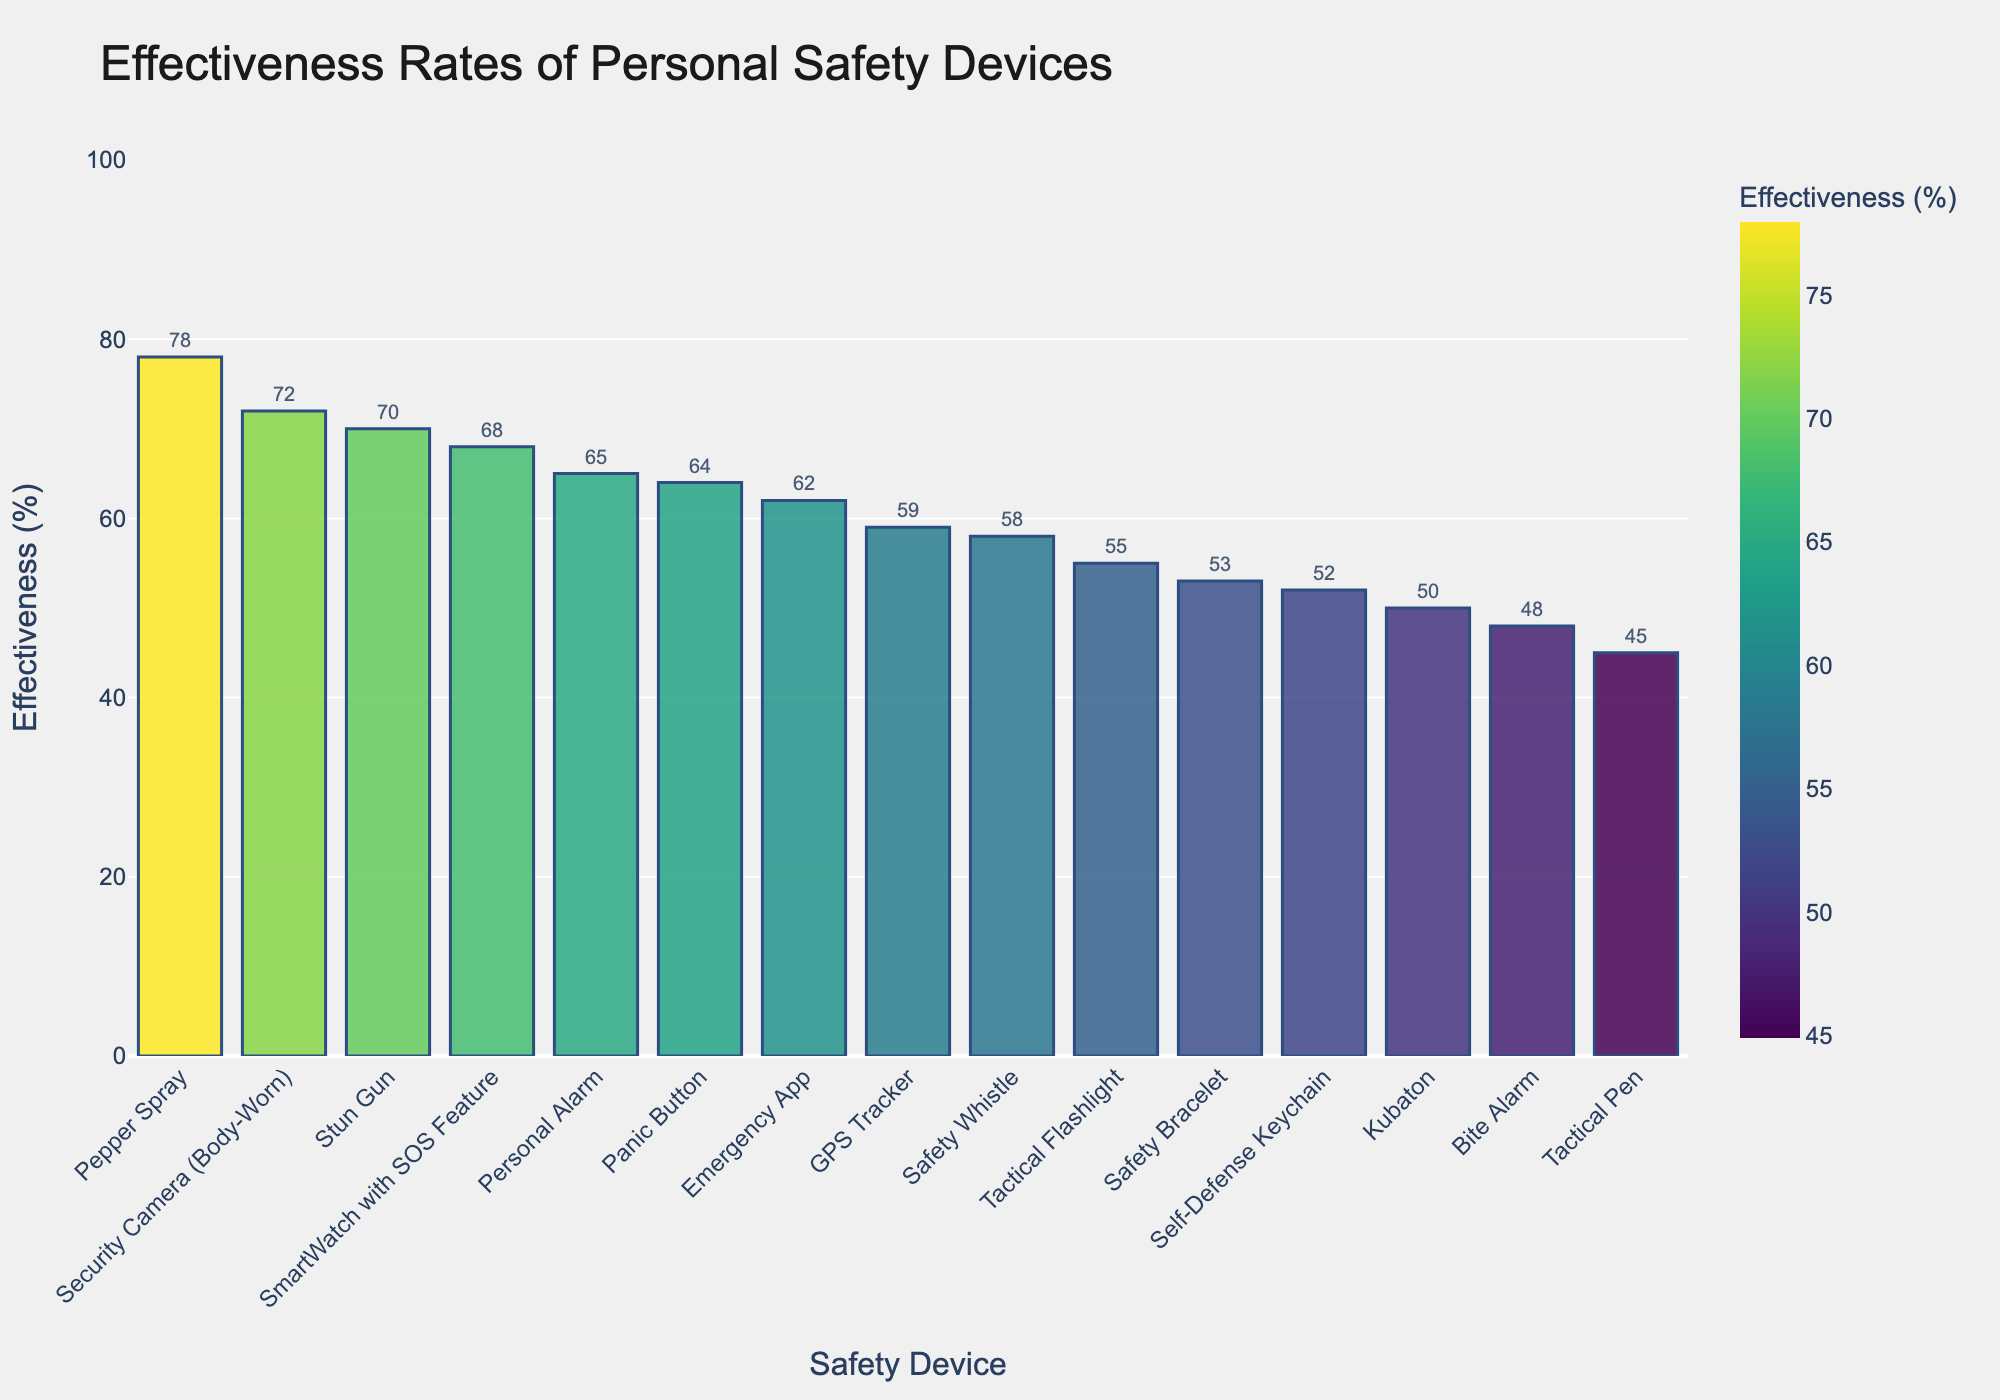What's the effectiveness rate of the personal alarm and the self-defense keychain combined? To find the combined effectiveness rate, add the effectiveness rates of the personal alarm (65) and the self-defense keychain (52). So, 65 + 52 = 117.
Answer: 117 Which device has a higher effectiveness rate: the tactical flashlight or the emergency app? Compare the effectiveness rates of the tactical flashlight (55) and the emergency app (62). Since 62 is greater than 55, the emergency app has a higher effectiveness rate.
Answer: Emergency App What's the average effectiveness rate of the top three devices? Identify the top three devices by their effectiveness rates: Pepper Spray (78), Security Camera (72), and Stun Gun (70). Add these rates together: 78 + 72 + 70 = 220, and then divide by 3 to get the average: 220/3 ≈ 73.33.
Answer: 73.33 Which device is in the middle of the effectiveness rate ranking? Sort the devices by their effectiveness rates in descending order and find the middle element. Since there are 15 devices, the middle one is the 8th device in the ranking. The 8th device is the GPS Tracker with an effectiveness rate of 59%.
Answer: GPS Tracker Are there more devices with an effectiveness rate above 60% or below 60%? Count the number of devices above 60% and below 60%. Devices above 60%: Pepper Spray, Stun Gun, Security Camera, SmartWatch with SOS Feature, Emergency App, Personal Alarm, and Panic Button (7 devices). Devices below 60%: Tactical Flashlight, Bite Alarm, Safety Whistle, Self-Defense Keychain, Cubaton, Tactical Pen, Safety Bracelet (8 devices).
Answer: Below 60% What's the total effectiveness rate of all the devices? Sum all the effectiveness rates: 78 + 65 + 52 + 70 + 45 + 58 + 50 + 62 + 55 + 68 + 48 + 53 + 64 + 59 + 72 = 899.
Answer: 899 Which device, among those with an effectiveness rate greater than 60%, has the lowest rate? Identify the devices with an effectiveness rate greater than 60%, then find the one with the lowest rate among them. These devices are Pepper Spray (78), Stun Gun (70), Security Camera (72), SmartWatch with SOS Feature (68), Emergency App (62), Personal Alarm (65), and Panic Button (64). The lowest is Emergency App with a rate of 62%.
Answer: Emergency App What’s the difference in effectiveness rate between the highest and lowest ranked devices? The highest effectiveness rate is for Pepper Spray (78) and the lowest is Tactical Pen (45). The difference is 78 - 45 = 33.
Answer: 33 